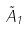<formula> <loc_0><loc_0><loc_500><loc_500>\tilde { A } _ { 1 }</formula> 